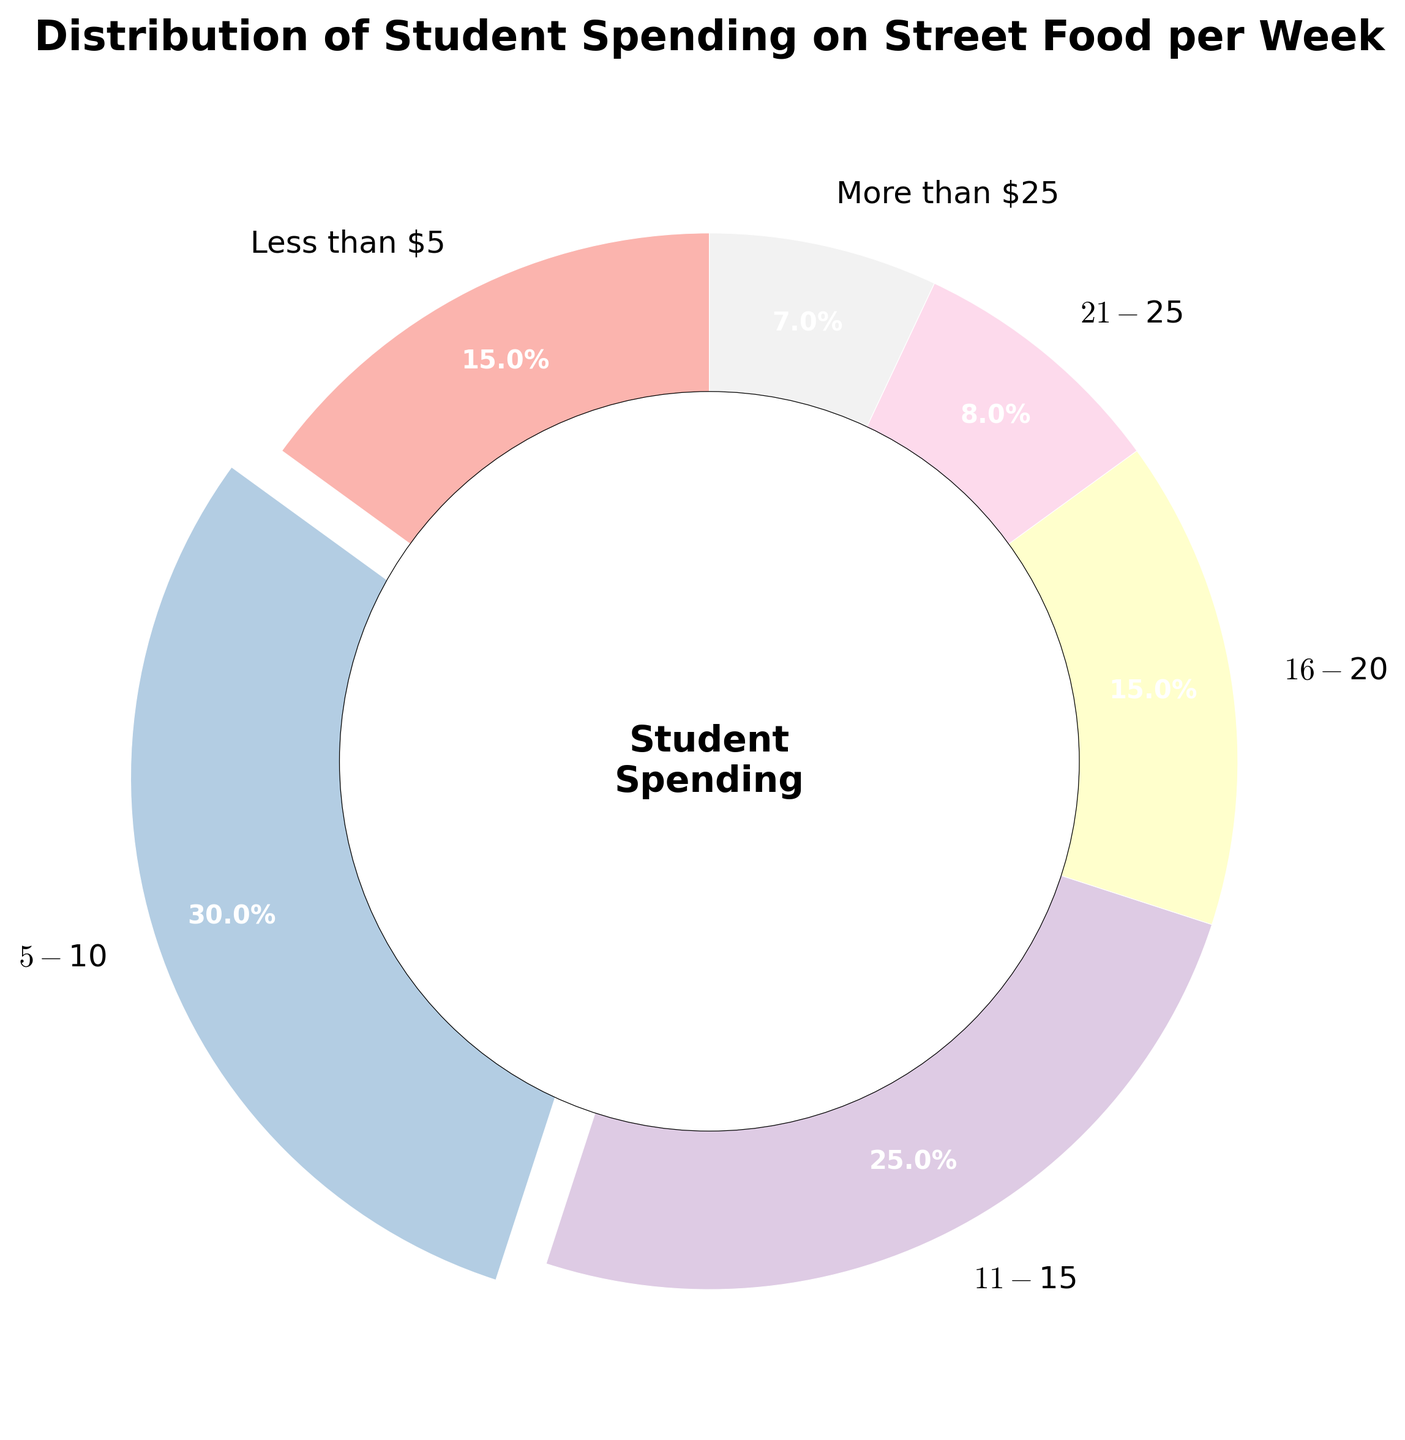What percentage of students spend less than $5 on street food per week? According to the pie chart, the segment labeled "Less than $5" indicates the percentage of students in this category.
Answer: 15% Which spending category has the highest percentage of students? By observing the pie chart, the largest segment has the label "$5 - $10".
Answer: $5 - $10 How many spending categories have a percentage of exactly 15%? There are two segments in the pie chart with the same percentage of 15%, they are labeled "Less than $5" and "$16 - $20".
Answer: 2 What is the total percentage of students that spend more than $15 on street food per week? According to the pie chart, we need to add the percentages for "$16 - $20", "$21 - $25", and "More than $25". Therefore, 15% + 8% + 7% = 30%.
Answer: 30% Which spending category has the smallest percentage of students? The smallest segment in the pie chart is labeled "More than $25".
Answer: More than $25 Do more students spend between $5 - $10 or $11 - $15 on street food per week? Comparing the segments, "$5 - $10" has a percentage of 30%, while "$11 - $15" has a percentage of 25%.
Answer: $5 - $10 What is the percentage difference between students spending $11 - $15 and those spending $16 - $20? The pie chart shows "$11 - $15" has 25% and "$16 - $20" has 15%. The difference is 25% - 15% = 10%.
Answer: 10% What color represents the category with the highest percentage of students? The color representing the largest segment, "$5 - $10", is found in the graphical representation specified by the pie chart.
Answer: Check the largest segment color Is the percentage of students spending less than $5 equal to those spending $16 - $20? By looking at the pie chart, we see that both "Less than $5" and "$16 - $20" have the same percentage of 15%.
Answer: Yes 